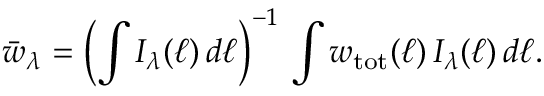<formula> <loc_0><loc_0><loc_500><loc_500>\bar { w } _ { \lambda } = \left ( \int I _ { \lambda } ( \ell ) \, d \ell \right ) ^ { - 1 } \, \int w _ { t o t } ( \ell ) \, I _ { \lambda } ( \ell ) \, d \ell .</formula> 